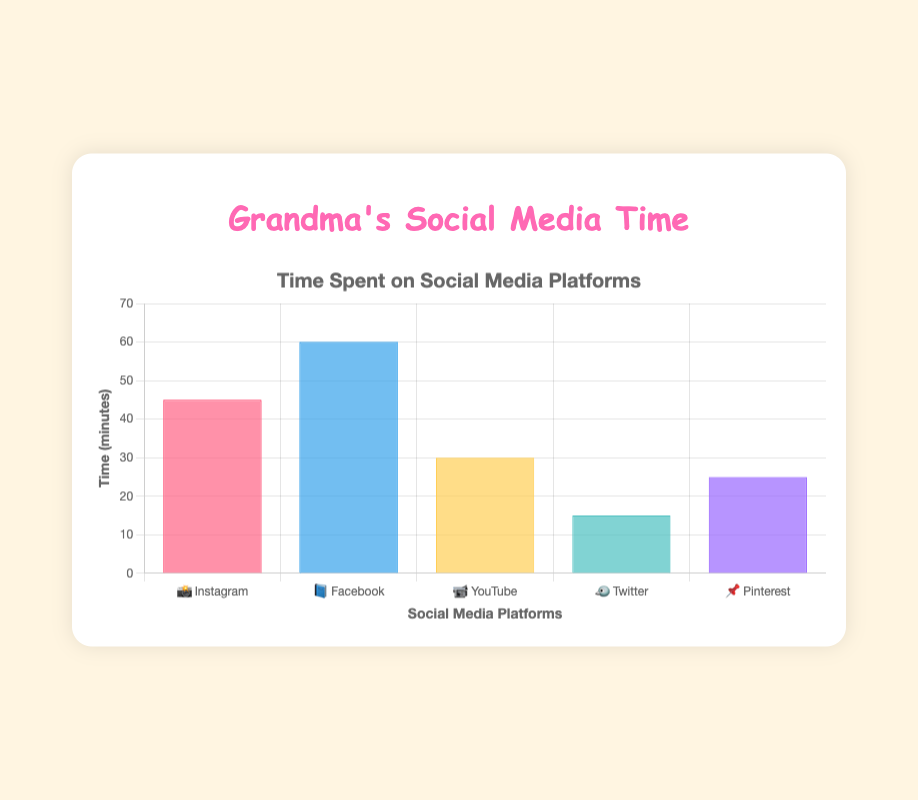What's the title of the chart? The title can be found at the top of the chart. It reads "Grandma's Social Media Time."
Answer: Grandma's Social Media Time Which social media platform did I spend the most time on? The platform with the tallest bar represents the most time spent. The bar for Facebook (📘) is the tallest, indicating 60 minutes.
Answer: Facebook (📘) How much time did I spend on Instagram (📸)? Look at the height of the bar labeled with Instagram's emoji (📸). The value associated is 45 minutes.
Answer: 45 minutes What is the difference in time spent between YouTube (📹) and Twitter (🐦)? YouTube has a bar height of 30 minutes, and Twitter has a bar height of 15 minutes. The difference is 30 - 15 = 15 minutes.
Answer: 15 minutes Which platform did I spend the least time on? The shortest bar indicates the least time spent. The bar for Twitter (🐦) is the shortest at 15 minutes.
Answer: Twitter (🐦) What is the total time spent on all platforms combined? Add the heights of all bars: 45 (Instagram) + 60 (Facebook) + 30 (YouTube) + 15 (Twitter) + 25 (Pinterest) = 175 minutes.
Answer: 175 minutes How much more time did I spend on Facebook (📘) than Pinterest (📌)? Facebook's bar is 60 minutes, and Pinterest's bar is 25 minutes. The difference is 60 - 25 = 35 minutes.
Answer: 35 minutes On which platform did I spend double the time compared to Twitter (🐦)? Twitter time is 15 minutes. Double of 15 is 30 minutes. The bar with 30 minutes is YouTube (📹).
Answer: YouTube (📹) What is the average time spent on the social media platforms? The total time spent is 175 minutes across 5 platforms. The average is 175 / 5 = 35 minutes.
Answer: 35 minutes Which platform has the second highest time spent? The highest time is Facebook (📘) with 60 minutes. The second highest bar is Instagram (📸) at 45 minutes.
Answer: Instagram (📸) 